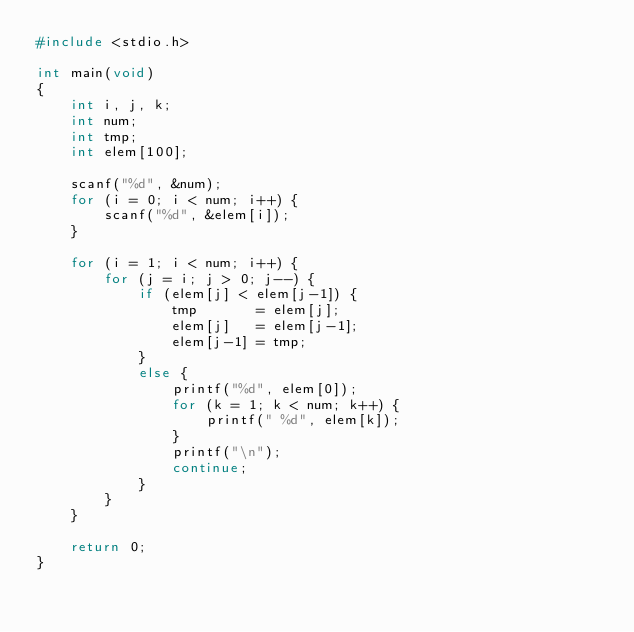<code> <loc_0><loc_0><loc_500><loc_500><_C++_>#include <stdio.h>

int main(void)
{
    int i, j, k;
    int num;
    int tmp;
    int elem[100];

    scanf("%d", &num);
    for (i = 0; i < num; i++) {
        scanf("%d", &elem[i]);
    }

    for (i = 1; i < num; i++) {
        for (j = i; j > 0; j--) {
            if (elem[j] < elem[j-1]) {
                tmp       = elem[j];
                elem[j]   = elem[j-1];
                elem[j-1] = tmp;
            }
            else {
                printf("%d", elem[0]);
                for (k = 1; k < num; k++) {
                    printf(" %d", elem[k]);
                }
                printf("\n");
                continue;
            }
        }
    }

    return 0;
}</code> 